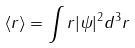Convert formula to latex. <formula><loc_0><loc_0><loc_500><loc_500>\langle r \rangle = \int r | \psi | ^ { 2 } d ^ { 3 } r</formula> 